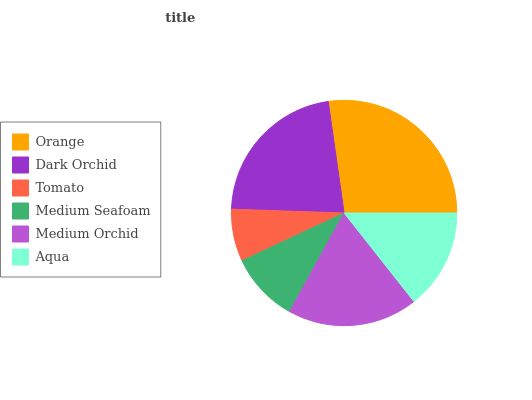Is Tomato the minimum?
Answer yes or no. Yes. Is Orange the maximum?
Answer yes or no. Yes. Is Dark Orchid the minimum?
Answer yes or no. No. Is Dark Orchid the maximum?
Answer yes or no. No. Is Orange greater than Dark Orchid?
Answer yes or no. Yes. Is Dark Orchid less than Orange?
Answer yes or no. Yes. Is Dark Orchid greater than Orange?
Answer yes or no. No. Is Orange less than Dark Orchid?
Answer yes or no. No. Is Medium Orchid the high median?
Answer yes or no. Yes. Is Aqua the low median?
Answer yes or no. Yes. Is Tomato the high median?
Answer yes or no. No. Is Orange the low median?
Answer yes or no. No. 